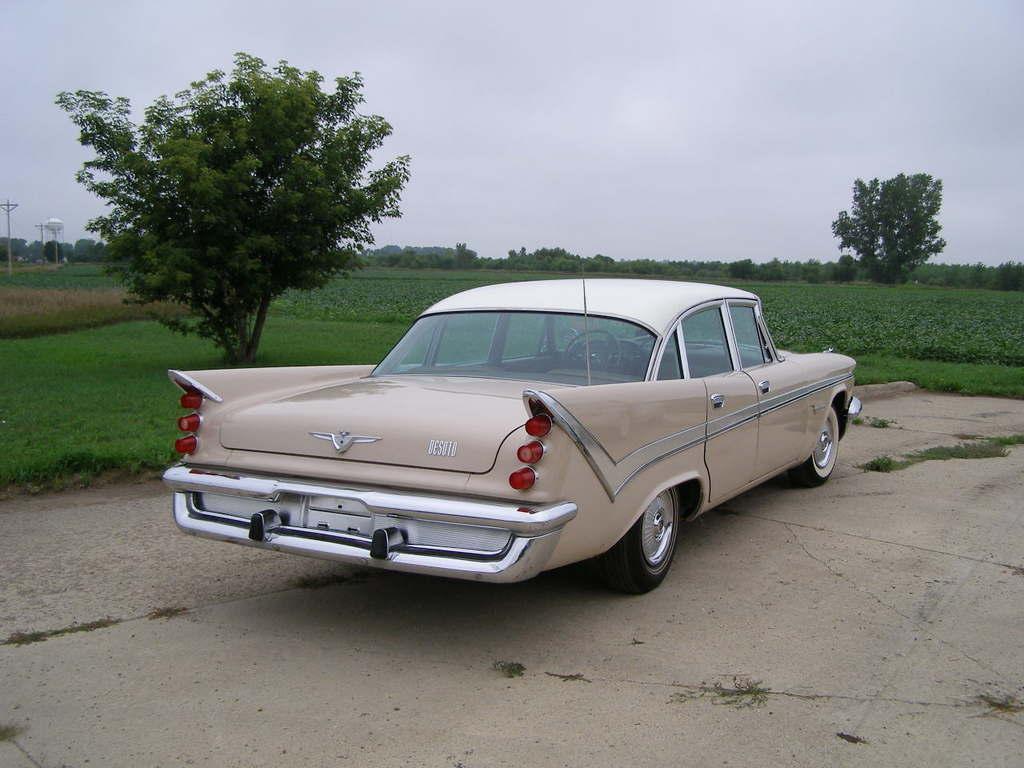Describe this image in one or two sentences. In this image, we can see a vehicle. We can see the ground. We can see some grass, plants and trees. We can also see some poles and the sky. We can also see a white colored object. 